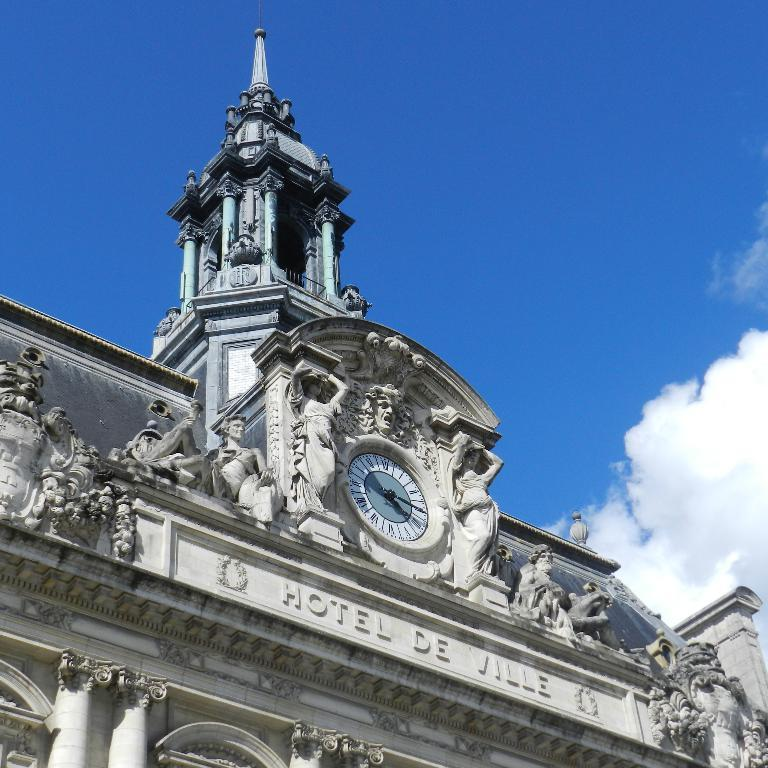<image>
Give a short and clear explanation of the subsequent image. Hotel De Ville has a large steeple and clock above its name 